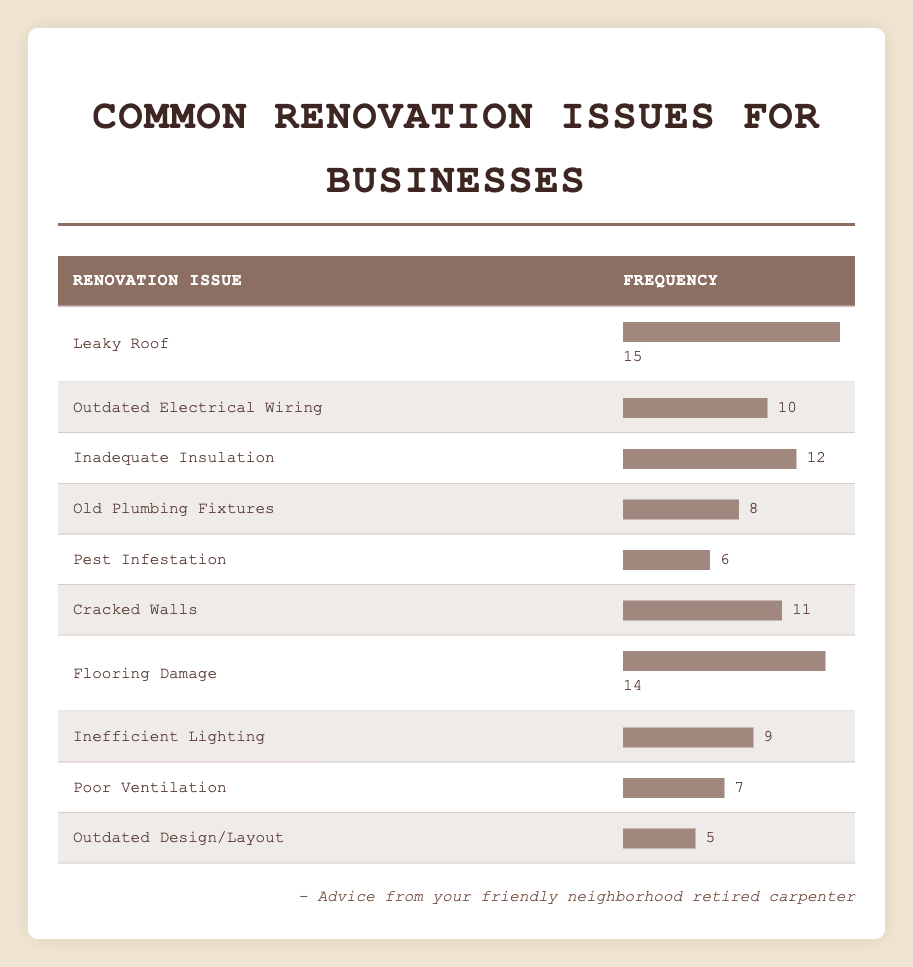What is the most common renovation issue faced by business owners? The data shows that "Leaky Roof" has the highest frequency at 15. Thus, it is the most common issue.
Answer: Leaky Roof How many issues have a frequency of 10 or more? By inspecting the table, I see that "Leaky Roof," "Inadequate Insulation," "Cracked Walls," "Flooring Damage," and "Outdated Electrical Wiring" all have frequencies of 10 or more, totaling 5 issues.
Answer: 5 Is "Pest Infestation" a common renovation issue? "Pest Infestation" has a frequency of 6, which is the lowest compared to other issues, suggesting it is less common.
Answer: No What is the difference in frequency between the most common and least common renovation issues? The most common issue, "Leaky Roof," has a frequency of 15, and the least common issue, "Outdated Design/Layout," has a frequency of 5. The difference is 15 - 5 = 10.
Answer: 10 What is the average frequency of all renovation issues? To calculate the average, I sum all frequencies: 15 + 10 + 12 + 8 + 6 + 11 + 14 + 9 + 7 + 5 = 87. There are 10 issues, so the average is 87 / 10 = 8.7.
Answer: 8.7 Which renovation issue has a frequency closest to the average? The average frequency is 8.7. The issues with the closest frequencies are "Old Plumbing Fixtures" (8) and "Inefficient Lighting" (9).
Answer: Old Plumbing Fixtures and Inefficient Lighting Is there an issue with a frequency of exactly 7? The table shows that "Poor Ventilation" has a frequency of 7. Therefore, there is an issue that meets this criteria.
Answer: Yes How many issues have frequencies that are above the average? The average frequency is 8.7. The issues "Leaky Roof," "Inadequate Insulation," "Flooring Damage," "Cracked Walls," and "Outdated Electrical Wiring" all have frequencies above the average, totaling 5 issues.
Answer: 5 Which two issues together have a frequency totaling 20? By checking pairs of issues, "Leaky Roof" (15) and "Old Plumbing Fixtures" (8) combined total 23, while "Inadequate Insulation" (12) and "Flooring Damage" (14) total 26. The only one that adds up to exactly 20 is "Old Plumbing Fixtures" (8) and "Inefficient Lighting" (9) which totals 17. Thus, no combination equals 20 precisely.
Answer: No combination equals 20 